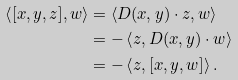Convert formula to latex. <formula><loc_0><loc_0><loc_500><loc_500>\left < [ x , y , z ] , w \right > & = \left < D ( x , y ) \cdot z , w \right > \\ & = - \left < z , D ( x , y ) \cdot w \right > \\ & = - \left < z , [ x , y , w ] \right > .</formula> 